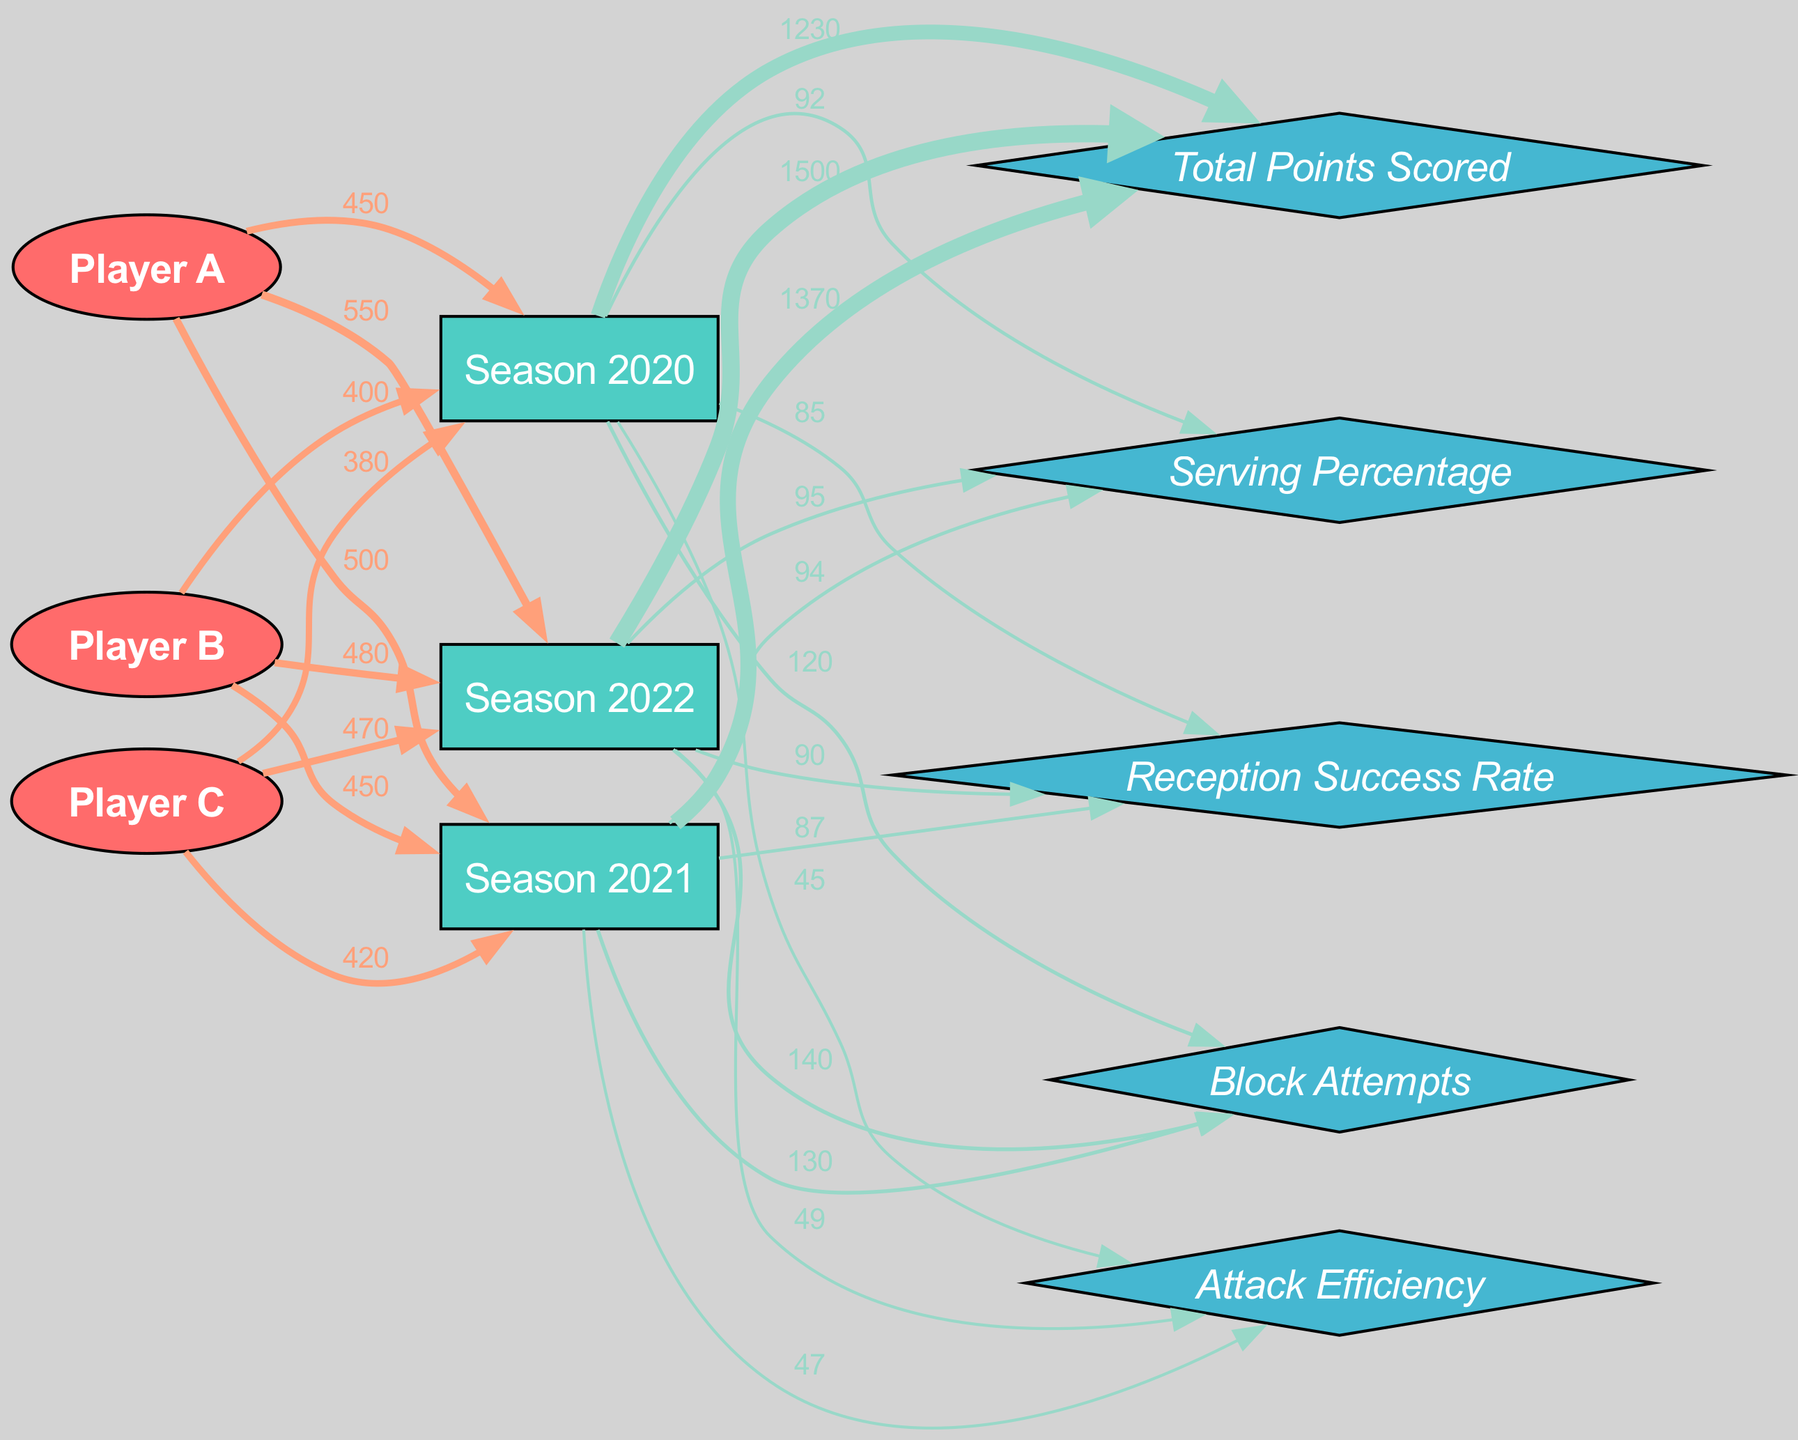What is the total points scored in Season 2021? The diagram shows a direct flow from "Season 2021" to "Total Points Scored" with a value of 1370, indicating the total points scored for that season.
Answer: 1370 Which player scored the most points in Season 2022? To determine which player scored the most in 2022, we look at the flows from each player to "Season 2022": Player A has 550, Player B has 480, and Player C has 470. Player A has the highest score of 550.
Answer: Player A What is the serving percentage for Season 2020? The direct flow from "Season 2020" to "Serving Percentage" shows a value of 92, indicating the serving percentage for that year.
Answer: 92 How many block attempts were recorded in Season 2022? The link from "Season 2022" to "Block Attempts" displays a value of 140, representing the total block attempts for that season.
Answer: 140 Which season had the highest total points scored? By examining the flows to "Total Points Scored", we see values for each season: 1230 for 2020, 1370 for 2021, and 1500 for 2022. The highest value is 1500 for Season 2022.
Answer: Season 2022 What was the attack efficiency in Season 2021? The diagram indicates a flow from "Season 2021" to "Attack Efficiency" with a value of 47, representing the attack efficiency for that season.
Answer: 47 Which player had a reception success rate increase every season? Analyzing the links from "Season 2020" to "Reception Success Rate" shows 85, from 2021 shows 87, and from 2022 shows 90. This indicates that reception success rate increased for all players since all years showed increasing values.
Answer: All Players What is the value of block attempts for Player B? There are no direct links from players to block attempts; however, looking at all block attempts for each season, we can see the total for each season but not specific to Player B. Thus, we cannot answer this question regarding Player B directly. The data doesn't provide specifics per player in that metric.
Answer: Not available Which player has the highest total combined points across all seasons? Calculating total points for each player: Player A (450 + 500 + 550 = 1500), Player B (400 + 450 + 480 = 1330), Player C (380 + 420 + 470 = 1270). Player A has the highest combined total of 1500 points.
Answer: Player A 